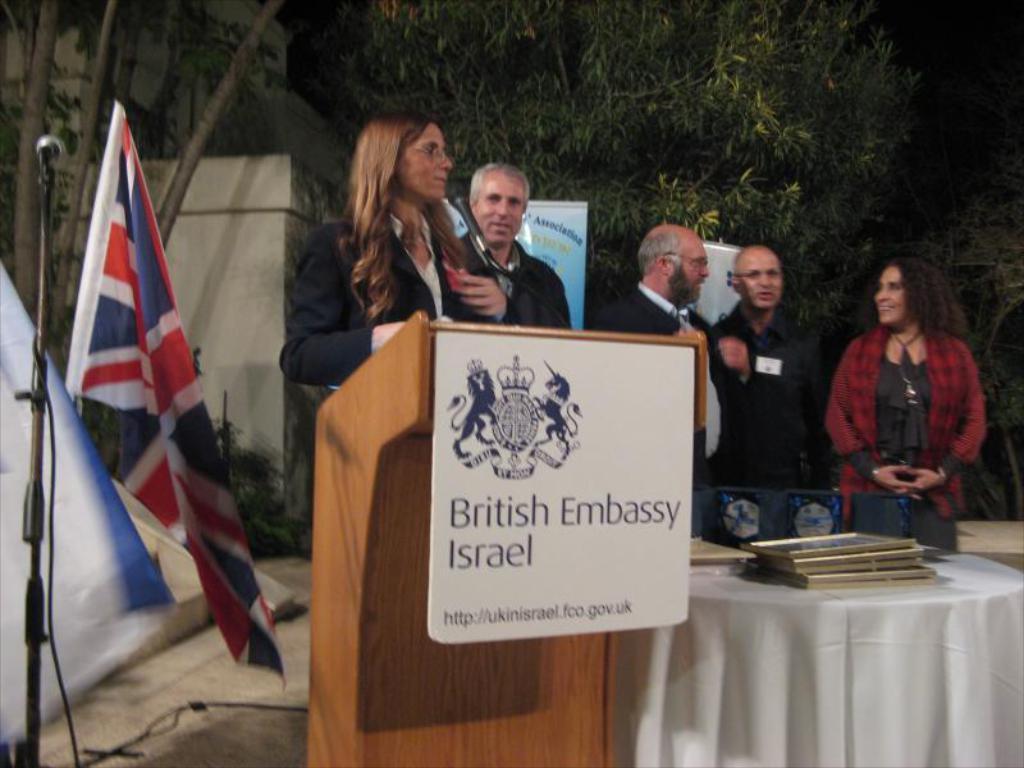In one or two sentences, can you explain what this image depicts? In this image there is a group of persons standing as we can see in the middle of this image. There are some trees in the background. There is a table in the bottom right corner of this image. There are some frames kept on it. There is a flag and Mic on the left side of this image. There is a building on the top of this image. There is a board in the middle of this image. 